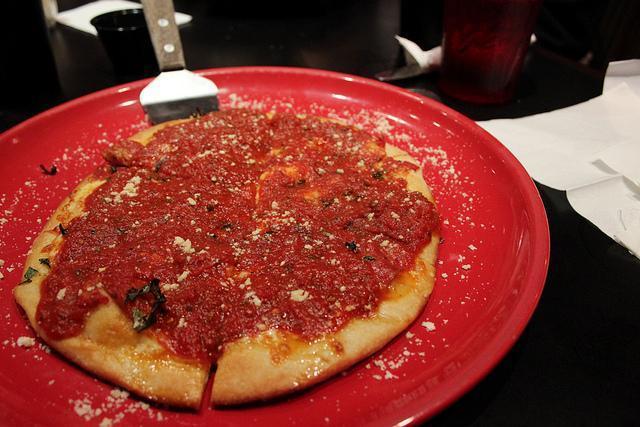Is this affirmation: "The pizza is off the dining table." correct?
Answer yes or no. No. 